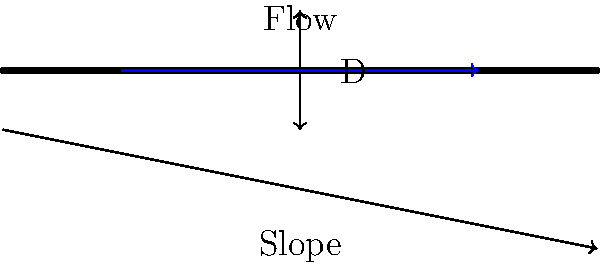As a volunteer in a brain chemistry study, you're tasked with calculating the flow rate through a circular pipe. The pipe has a diameter of 0.3 meters and a slope of 0.002. Using Manning's equation, determine the flow rate in cubic meters per second. Assume the Manning's roughness coefficient (n) is 0.013 for this pipe material.

Manning's equation: $Q = \frac{1}{n} A R^{\frac{2}{3}} S^{\frac{1}{2}}$

Where:
$Q$ = flow rate (m³/s)
$n$ = Manning's roughness coefficient
$A$ = cross-sectional area of flow (m²)
$R$ = hydraulic radius (m)
$S$ = slope of the hydraulic grade line (m/m) Let's solve this step-by-step:

1) First, calculate the cross-sectional area (A):
   $A = \pi r^2 = \pi (\frac{D}{2})^2 = \pi (\frac{0.3}{2})^2 = 0.0707 \text{ m}^2$

2) Calculate the wetted perimeter (P):
   $P = \pi D = \pi (0.3) = 0.9425 \text{ m}$

3) Calculate the hydraulic radius (R):
   $R = \frac{A}{P} = \frac{0.0707}{0.9425} = 0.0750 \text{ m}$

4) We know the following:
   $n = 0.013$ (given)
   $S = 0.002$ (given)

5) Now, plug everything into Manning's equation:
   $Q = \frac{1}{n} A R^{\frac{2}{3}} S^{\frac{1}{2}}$
   $Q = \frac{1}{0.013} (0.0707) (0.0750)^{\frac{2}{3}} (0.002)^{\frac{1}{2}}$

6) Calculate:
   $Q = 76.92 \times 0.0707 \times 0.1827 \times 0.0447$
   $Q = 0.0446 \text{ m}^3/\text{s}$

Therefore, the flow rate through the pipe is approximately 0.0446 cubic meters per second.
Answer: 0.0446 m³/s 